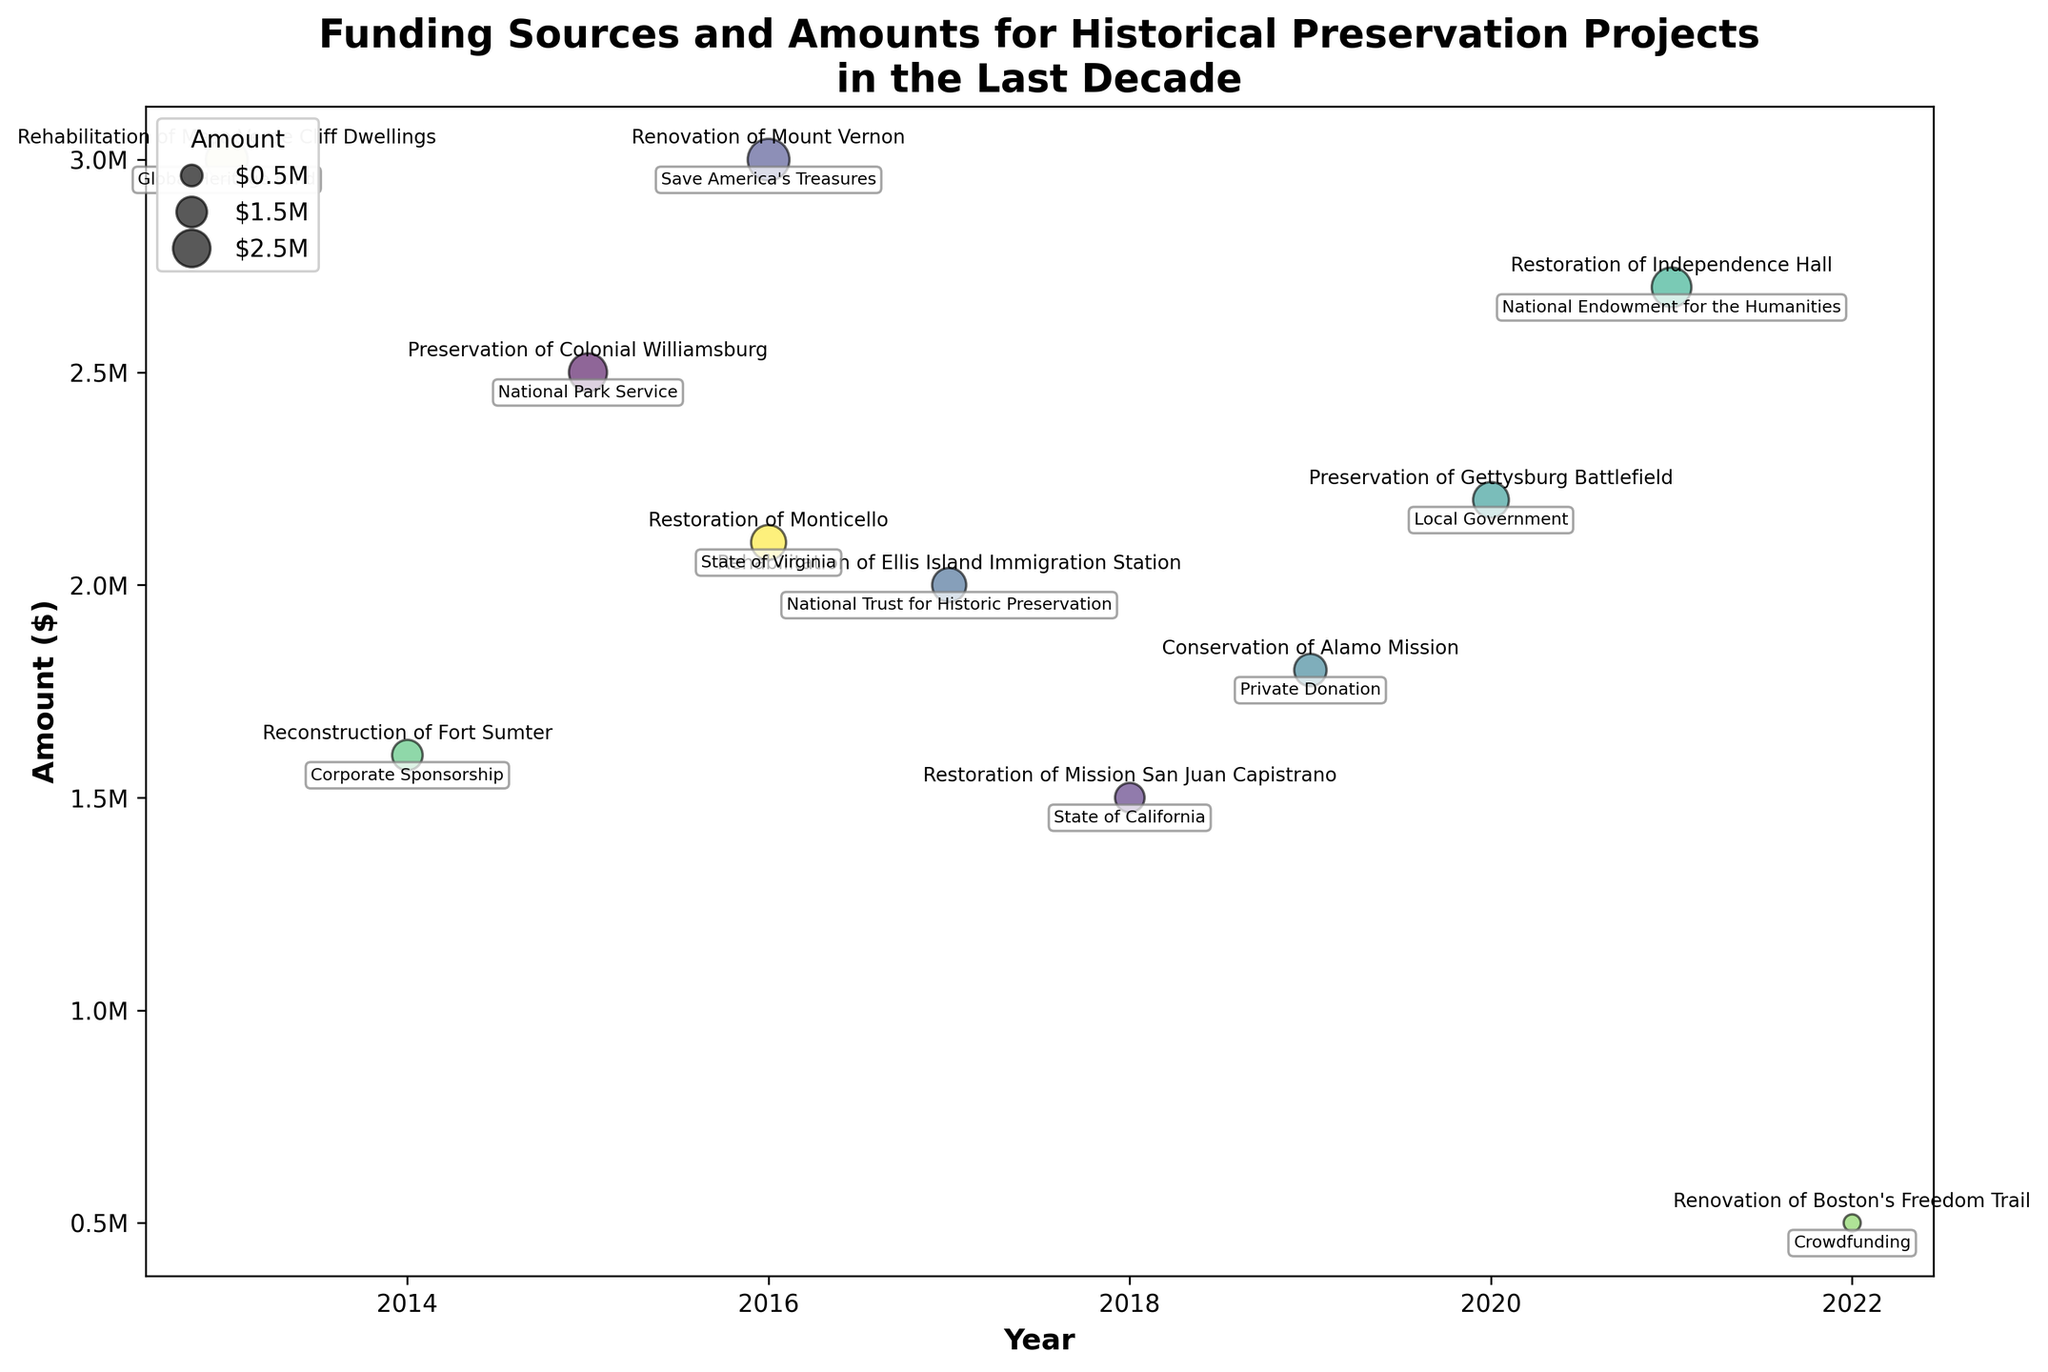What is the title of the chart? The title is prominently displayed at the top of the chart. It reads "Funding Sources and Amounts for Historical Preservation Projects in the Last Decade".
Answer: "Funding Sources and Amounts for Historical Preservation Projects in the Last Decade" How many different funding sources are shown in the chart? By counting the unique bubbles labeled with the funding sources, we can determine there are 11 different sources.
Answer: 11 Which year received the highest funding amount for a single project? By examining the size and positioning of the bubbles on the y-axis, the largest amount corresponds to the year 2013 for the project "Rehabilitation of Mesa Verde Cliff Dwellings", amounting to $3,000,000.
Answer: 2013 What source provided the highest funding and for which project? By identifying the largest bubble and reading its label, the highest funding of $3,000,000 was provided by the Global Heritage Fund for the "Rehabilitation of Mesa Verde Cliff Dwellings".
Answer: Global Heritage Fund, Rehabilitation of Mesa Verde Cliff Dwellings Which project had the smallest funding amount, and which source funded it? By looking for the smallest bubble and reading the label, the project "Renovation of Boston's Freedom Trail" received the smallest funding of $500,000, which was funded by Crowdfunding.
Answer: Renovation of Boston's Freedom Trail, Crowdfunding How many projects were funded in 2016, and what is the total amount received in that year? By counting the bubbles placed on the year 2016 along the x-axis, there are 2 projects. Adding the amounts gives $3,000,000 + $2,100,000 = $5,100,000.
Answer: 2 projects, $5,100,000 Which funding source contributed to more than one project? By reading the labels of bubbles and matching sources, no funding source is repeated for multiple projects.
Answer: None Compare the funding amounts between the "Preservation of Colonial Williamsburg" and "Rehabilitation of Ellis Island Immigration Station." Which received more funding and by how much? By comparing the sizes of the bubbles, "Preservation of Colonial Williamsburg" received $2,500,000 while "Rehabilitation of Ellis Island Immigration Station" received $2,000,000. The difference is $2,500,000 - $2,000,000 = $500,000.
Answer: Preservation of Colonial Williamsburg, by $500,000 What is the trend in funding amounts from 2013 to 2022? Observing the y-axis values and bubble sizes over the years 2013 to 2022, there is no clear increasing or decreasing trend; the funding amounts vary without a distinct pattern.
Answer: No clear trend What is the average funding amount for the projects shown in the chart? Adding all the funding amounts: $2,500,000 + $1,500,000 + $3,000,000 + $2,000,000 + $1,800,000 + $2,200,000 + $2,700,000 + $1,600,000 + $500,000 + $3,000,000 + $2,100,000 = $22,900,000. Dividing by the number of projects (11), the average is $22,900,000/11 = $2,081,818 (rounded to nearest dollar).
Answer: $2,081,818 